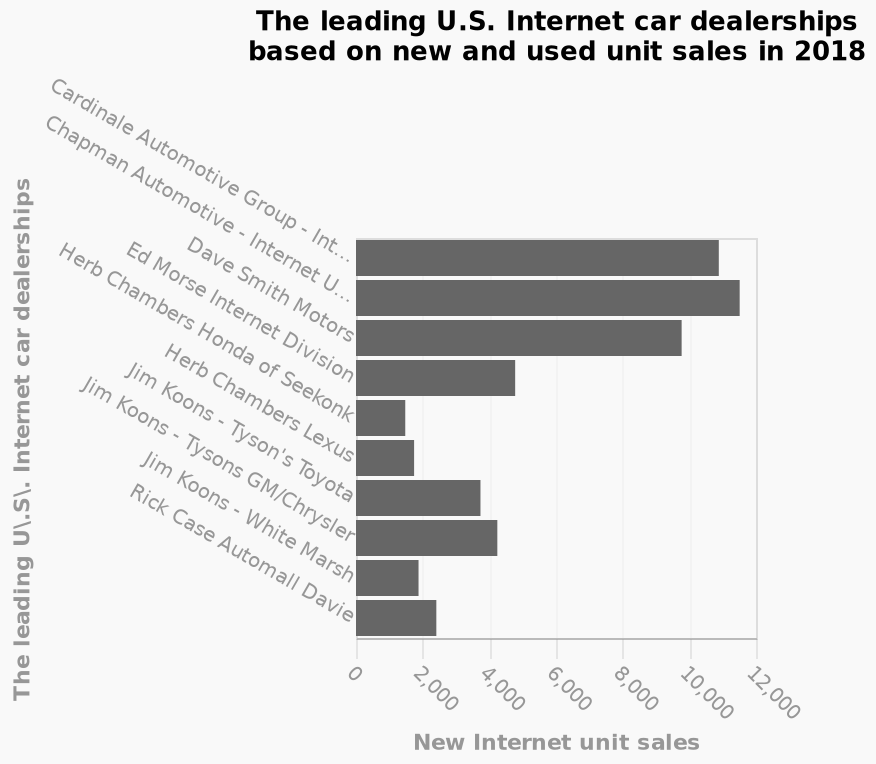<image>
Which dealership is at the beginning of the y-axis scale?  Cardinale Automotive Group - Internet Unit. Describe the following image in detail Here a bar graph is labeled The leading U.S. Internet car dealerships based on new and used unit sales in 2018. Along the y-axis, The leading U\.S\. Internet car dealerships is drawn with a categorical scale starting at Cardinale Automotive Group - Internet Unit and ending at Rick Case Automall Davie. There is a linear scale with a minimum of 0 and a maximum of 12,000 on the x-axis, labeled New Internet unit sales. What is the unit sales of the top 4 competitors? The top 4 competitors, including Chapman automotive, Cardinals Automotive Group, Dave Smith Motors, and Ed Morse internet Division, are all making unit sales of over 9,500. 